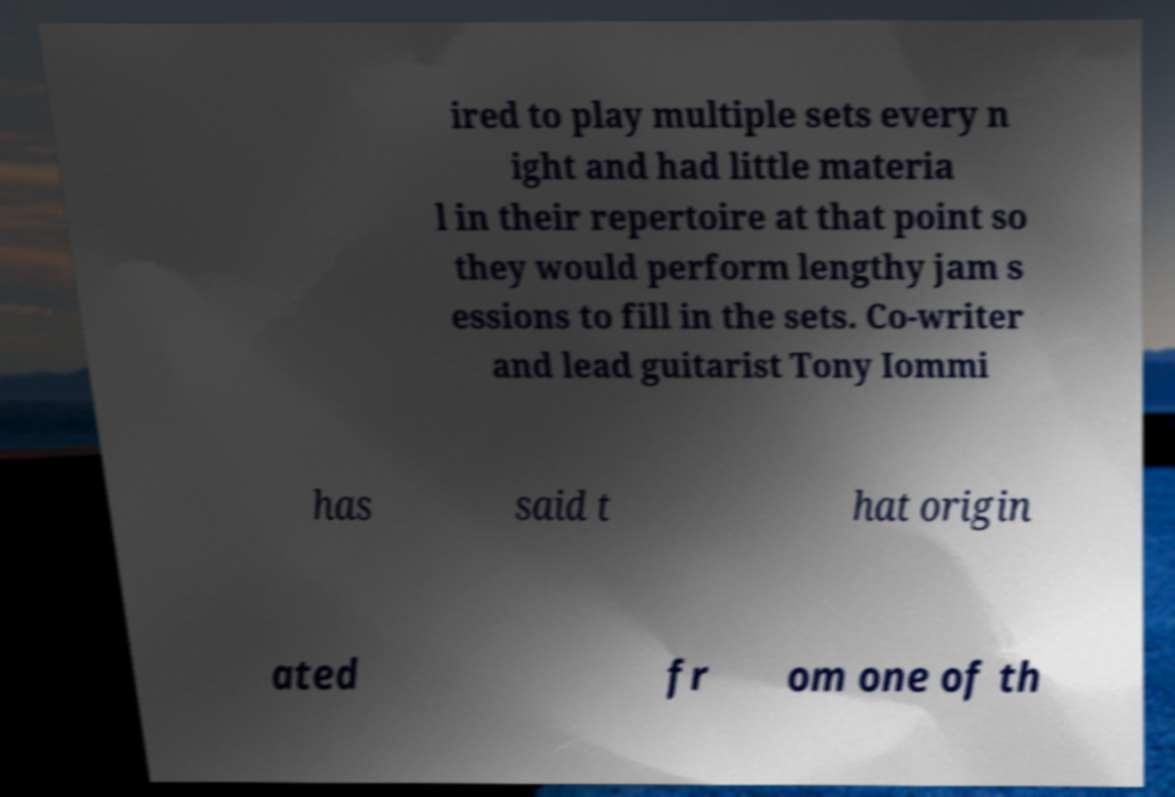Could you assist in decoding the text presented in this image and type it out clearly? ired to play multiple sets every n ight and had little materia l in their repertoire at that point so they would perform lengthy jam s essions to fill in the sets. Co-writer and lead guitarist Tony Iommi has said t hat origin ated fr om one of th 